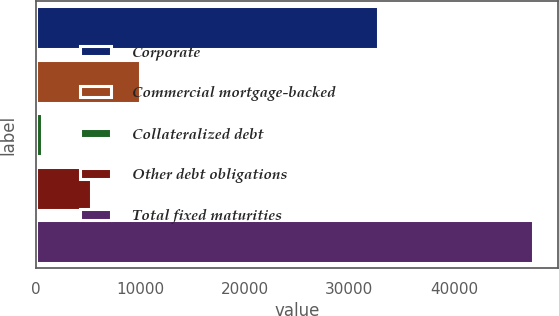Convert chart to OTSL. <chart><loc_0><loc_0><loc_500><loc_500><bar_chart><fcel>Corporate<fcel>Commercial mortgage-backed<fcel>Collateralized debt<fcel>Other debt obligations<fcel>Total fixed maturities<nl><fcel>32767<fcel>10009.3<fcel>607.5<fcel>5308.39<fcel>47616.4<nl></chart> 